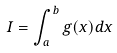<formula> <loc_0><loc_0><loc_500><loc_500>I = \int _ { a } ^ { b } g ( x ) d x</formula> 